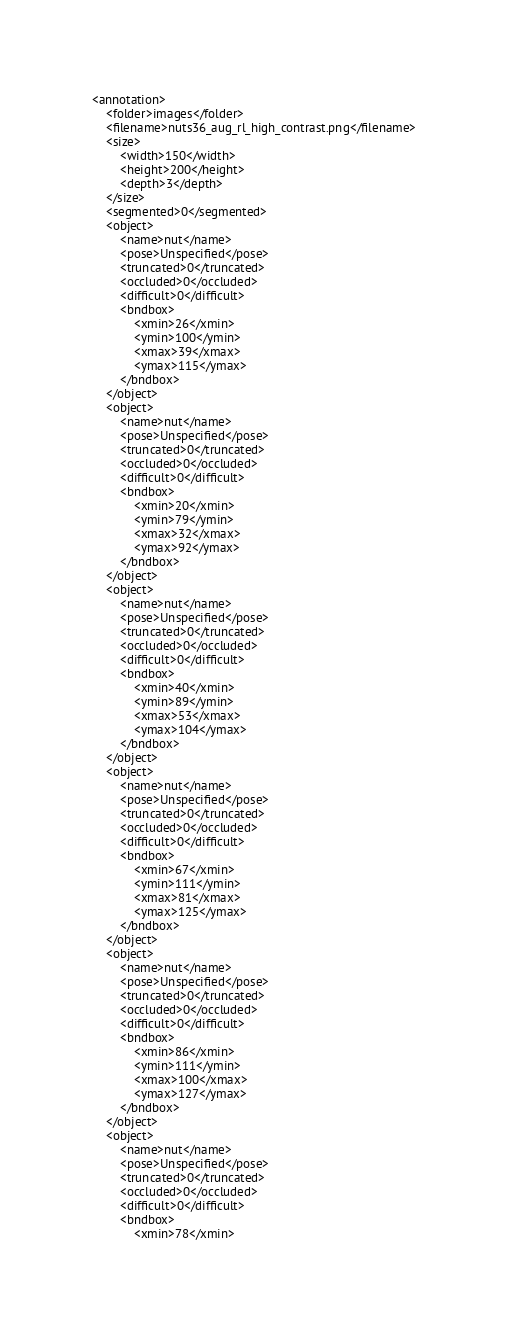<code> <loc_0><loc_0><loc_500><loc_500><_XML_><annotation>
    <folder>images</folder>
    <filename>nuts36_aug_rl_high_contrast.png</filename>
    <size>
        <width>150</width>
        <height>200</height>
        <depth>3</depth>
    </size>
    <segmented>0</segmented>
    <object>
        <name>nut</name>
        <pose>Unspecified</pose>
        <truncated>0</truncated>
        <occluded>0</occluded>
        <difficult>0</difficult>
        <bndbox>
            <xmin>26</xmin>
            <ymin>100</ymin>
            <xmax>39</xmax>
            <ymax>115</ymax>
        </bndbox>
    </object>
    <object>
        <name>nut</name>
        <pose>Unspecified</pose>
        <truncated>0</truncated>
        <occluded>0</occluded>
        <difficult>0</difficult>
        <bndbox>
            <xmin>20</xmin>
            <ymin>79</ymin>
            <xmax>32</xmax>
            <ymax>92</ymax>
        </bndbox>
    </object>
    <object>
        <name>nut</name>
        <pose>Unspecified</pose>
        <truncated>0</truncated>
        <occluded>0</occluded>
        <difficult>0</difficult>
        <bndbox>
            <xmin>40</xmin>
            <ymin>89</ymin>
            <xmax>53</xmax>
            <ymax>104</ymax>
        </bndbox>
    </object>
    <object>
        <name>nut</name>
        <pose>Unspecified</pose>
        <truncated>0</truncated>
        <occluded>0</occluded>
        <difficult>0</difficult>
        <bndbox>
            <xmin>67</xmin>
            <ymin>111</ymin>
            <xmax>81</xmax>
            <ymax>125</ymax>
        </bndbox>
    </object>
    <object>
        <name>nut</name>
        <pose>Unspecified</pose>
        <truncated>0</truncated>
        <occluded>0</occluded>
        <difficult>0</difficult>
        <bndbox>
            <xmin>86</xmin>
            <ymin>111</ymin>
            <xmax>100</xmax>
            <ymax>127</ymax>
        </bndbox>
    </object>
    <object>
        <name>nut</name>
        <pose>Unspecified</pose>
        <truncated>0</truncated>
        <occluded>0</occluded>
        <difficult>0</difficult>
        <bndbox>
            <xmin>78</xmin></code> 